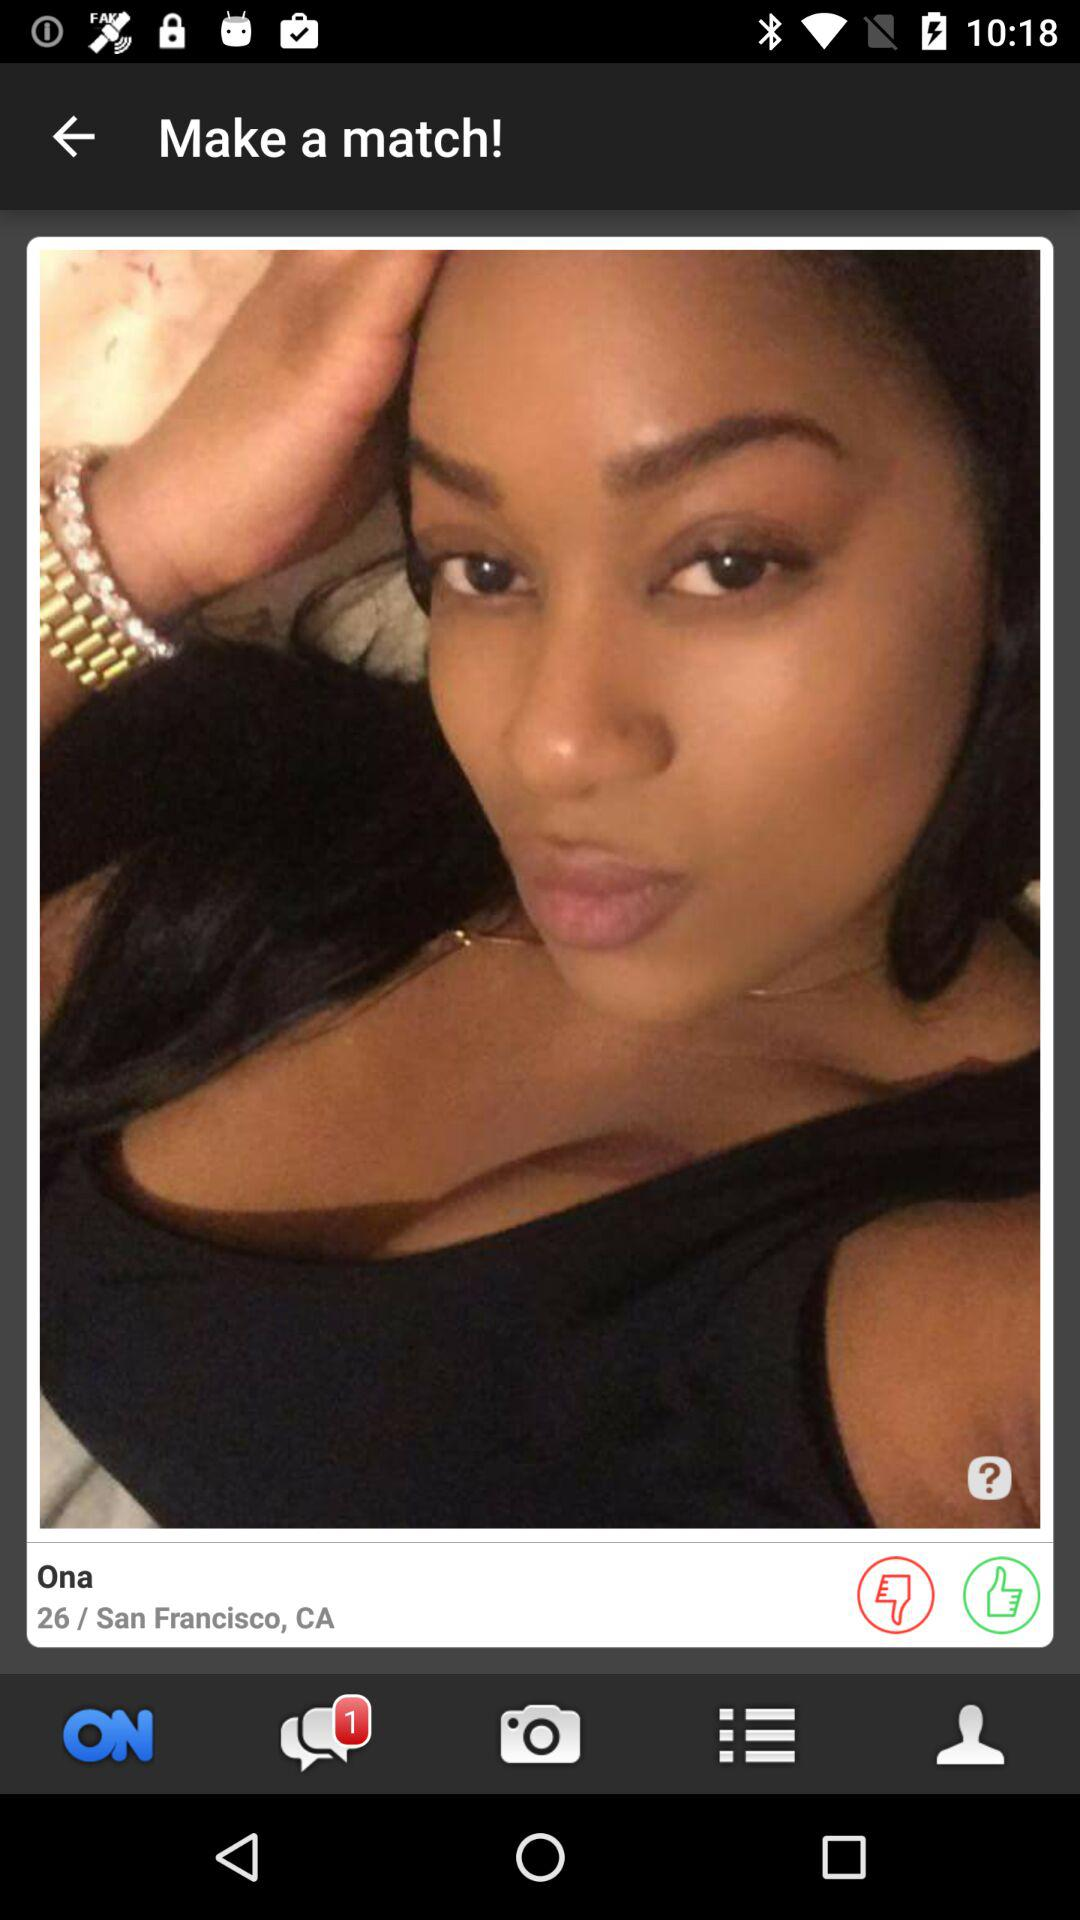What's the user's age? The user is 26 years old. 